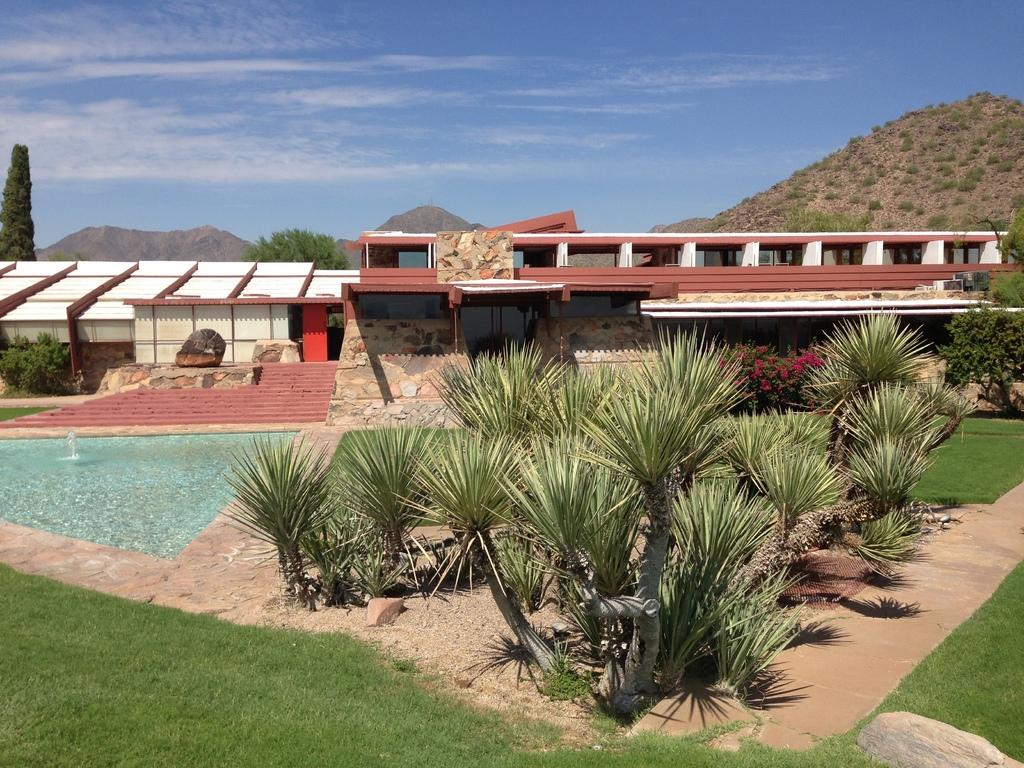What type of vegetation can be seen in the image? There are trees and grass visible in the image. What natural element is present in the image? Water is visible in the image. What architectural feature is present in the image? There are stairs in front of a building in the image. What can be seen in the background of the image? Mountains, trees, and the sky are visible in the background of the image. What is the condition of the sky in the image? Clouds are present in the sky. How many letters are being transported by the lift in the image? There is no lift or letters present in the image. What type of transport is used to move the trees in the image? There is no transport or movement of trees in the image; they are stationary. 